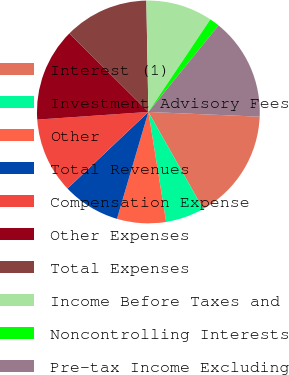Convert chart. <chart><loc_0><loc_0><loc_500><loc_500><pie_chart><fcel>Interest (1)<fcel>Investment Advisory Fees<fcel>Other<fcel>Total Revenues<fcel>Compensation Expense<fcel>Other Expenses<fcel>Total Expenses<fcel>Income Before Taxes and<fcel>Noncontrolling Interests<fcel>Pre-tax Income Excluding<nl><fcel>16.13%<fcel>5.65%<fcel>7.1%<fcel>8.39%<fcel>10.97%<fcel>13.55%<fcel>12.26%<fcel>9.68%<fcel>1.45%<fcel>14.84%<nl></chart> 